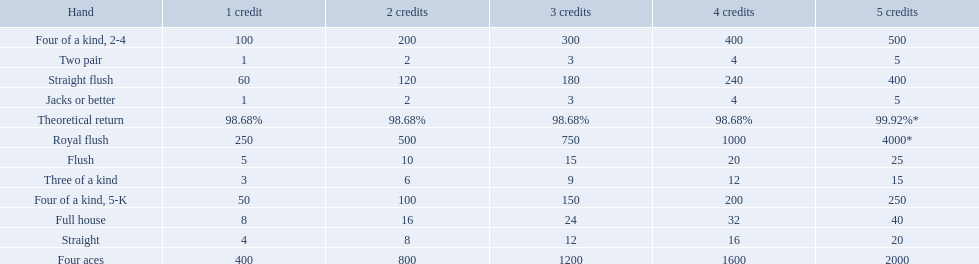What is the higher amount of points for one credit you can get from the best four of a kind 100. What type is it? Four of a kind, 2-4. 